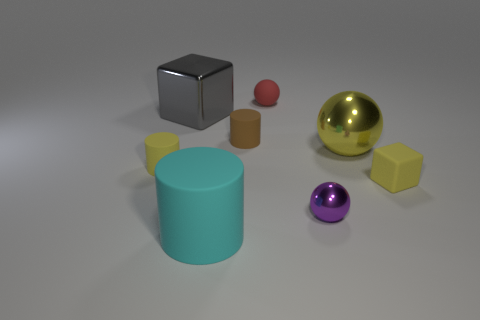Subtract all small red matte balls. How many balls are left? 2 Subtract 1 cylinders. How many cylinders are left? 2 Add 2 small purple metal objects. How many objects exist? 10 Subtract all spheres. How many objects are left? 5 Subtract all red cylinders. Subtract all purple balls. How many cylinders are left? 3 Add 8 purple things. How many purple things are left? 9 Add 7 small purple shiny things. How many small purple shiny things exist? 8 Subtract 0 brown spheres. How many objects are left? 8 Subtract all big blue metallic things. Subtract all big cyan cylinders. How many objects are left? 7 